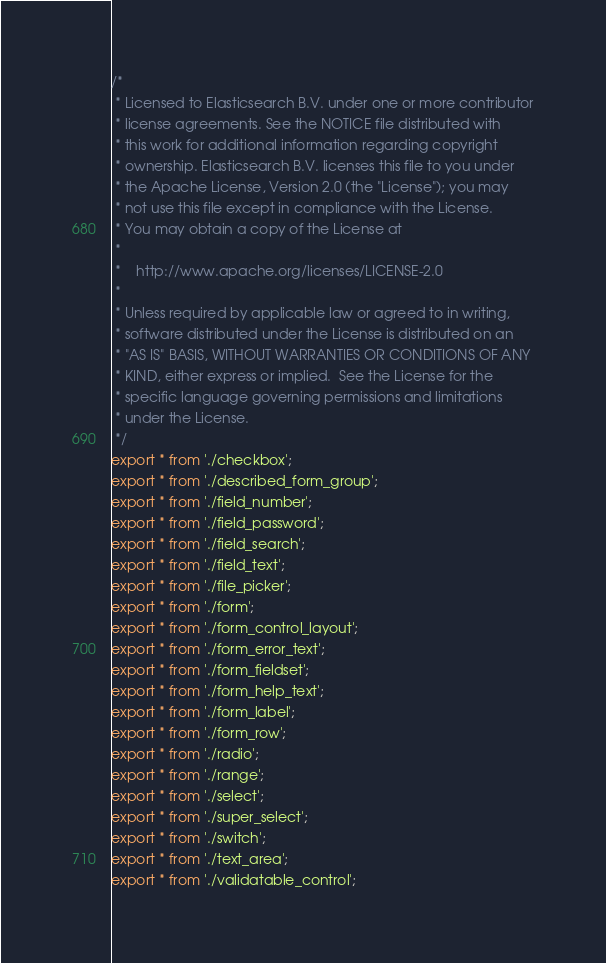Convert code to text. <code><loc_0><loc_0><loc_500><loc_500><_JavaScript_>/*
 * Licensed to Elasticsearch B.V. under one or more contributor
 * license agreements. See the NOTICE file distributed with
 * this work for additional information regarding copyright
 * ownership. Elasticsearch B.V. licenses this file to you under
 * the Apache License, Version 2.0 (the "License"); you may
 * not use this file except in compliance with the License.
 * You may obtain a copy of the License at
 *
 *    http://www.apache.org/licenses/LICENSE-2.0
 *
 * Unless required by applicable law or agreed to in writing,
 * software distributed under the License is distributed on an
 * "AS IS" BASIS, WITHOUT WARRANTIES OR CONDITIONS OF ANY
 * KIND, either express or implied.  See the License for the
 * specific language governing permissions and limitations
 * under the License.
 */
export * from './checkbox';
export * from './described_form_group';
export * from './field_number';
export * from './field_password';
export * from './field_search';
export * from './field_text';
export * from './file_picker';
export * from './form';
export * from './form_control_layout';
export * from './form_error_text';
export * from './form_fieldset';
export * from './form_help_text';
export * from './form_label';
export * from './form_row';
export * from './radio';
export * from './range';
export * from './select';
export * from './super_select';
export * from './switch';
export * from './text_area';
export * from './validatable_control';</code> 